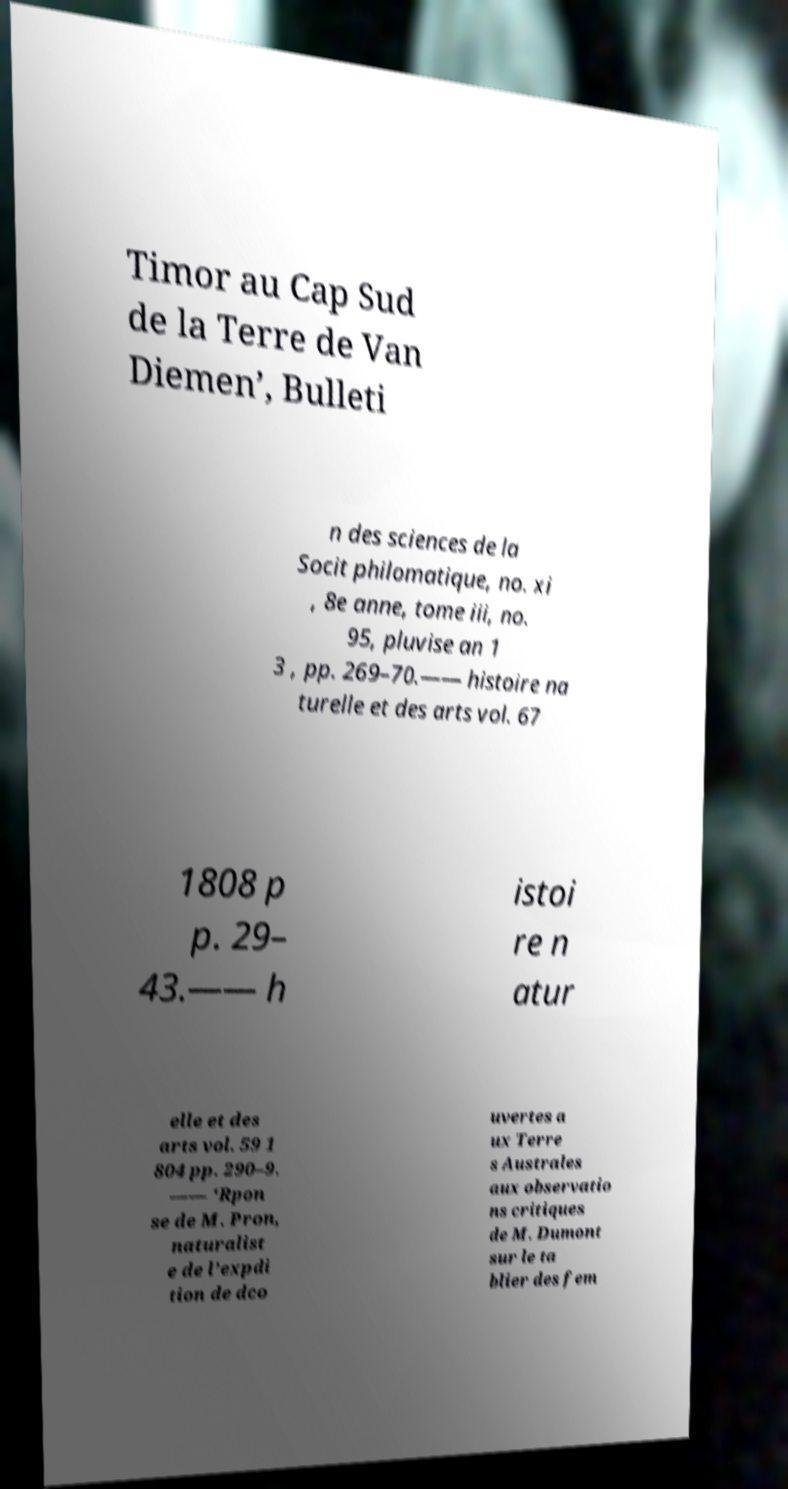There's text embedded in this image that I need extracted. Can you transcribe it verbatim? Timor au Cap Sud de la Terre de Van Diemen’, Bulleti n des sciences de la Socit philomatique, no. xi , 8e anne, tome iii, no. 95, pluvise an 1 3 , pp. 269–70.—— histoire na turelle et des arts vol. 67 1808 p p. 29– 43.—— h istoi re n atur elle et des arts vol. 59 1 804 pp. 290–9. —— ‘Rpon se de M. Pron, naturalist e de l’expdi tion de dco uvertes a ux Terre s Australes aux observatio ns critiques de M. Dumont sur le ta blier des fem 